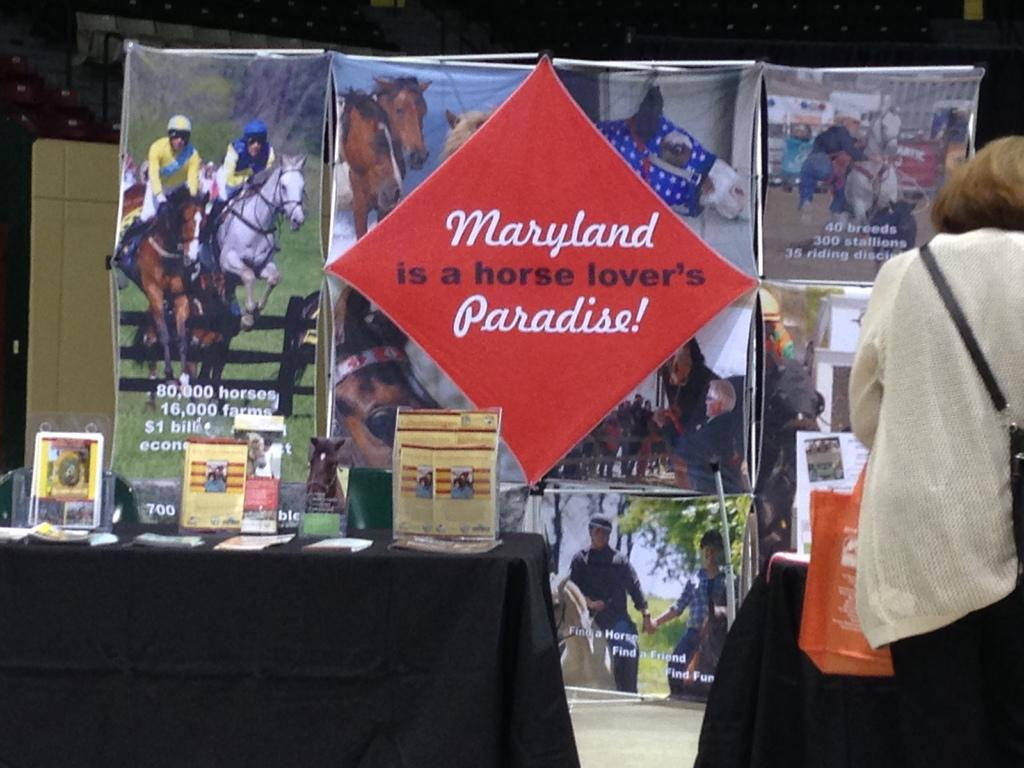<image>
Relay a brief, clear account of the picture shown. a display table with phampletes about Maryland and horses 